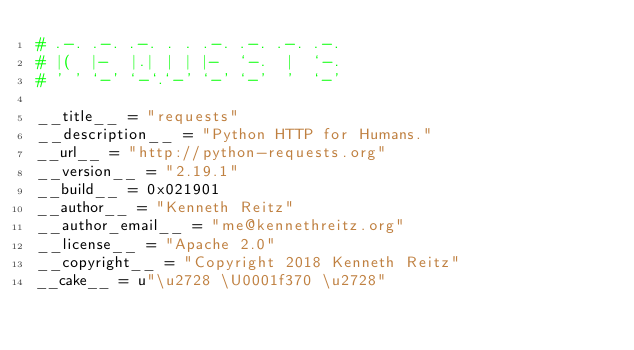Convert code to text. <code><loc_0><loc_0><loc_500><loc_500><_Python_># .-. .-. .-. . . .-. .-. .-. .-.
# |(  |-  |.| | | |-  `-.  |  `-.
# ' ' `-' `-`.`-' `-' `-'  '  `-'

__title__ = "requests"
__description__ = "Python HTTP for Humans."
__url__ = "http://python-requests.org"
__version__ = "2.19.1"
__build__ = 0x021901
__author__ = "Kenneth Reitz"
__author_email__ = "me@kennethreitz.org"
__license__ = "Apache 2.0"
__copyright__ = "Copyright 2018 Kenneth Reitz"
__cake__ = u"\u2728 \U0001f370 \u2728"
</code> 